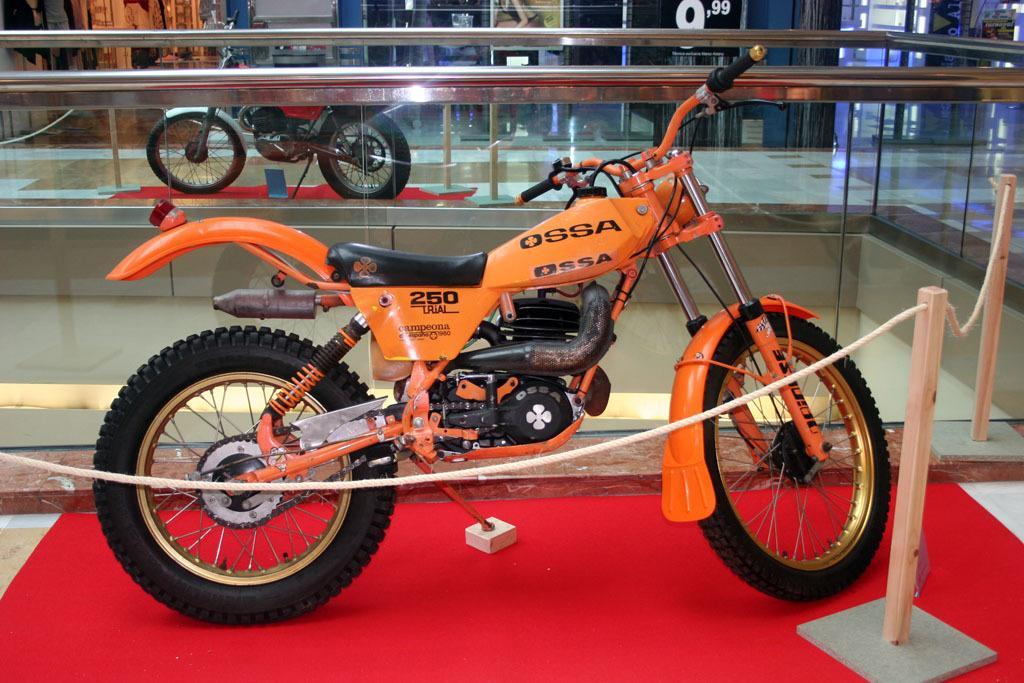Describe this image in one or two sentences. In this picture we can see orange color dirt bike parked in the showroom. In the front bottom side we can see the rope barriers. In the background we can see the black color posters on the wall. 